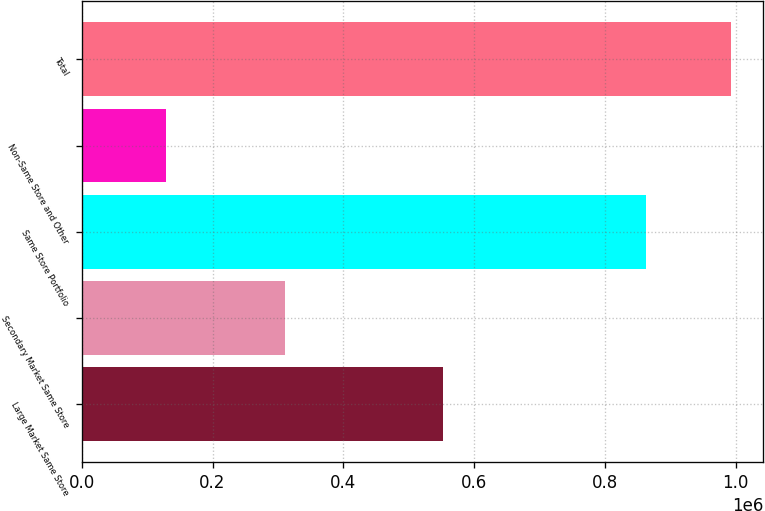<chart> <loc_0><loc_0><loc_500><loc_500><bar_chart><fcel>Large Market Same Store<fcel>Secondary Market Same Store<fcel>Same Store Portfolio<fcel>Non-Same Store and Other<fcel>Total<nl><fcel>553038<fcel>310281<fcel>863319<fcel>128859<fcel>992178<nl></chart> 